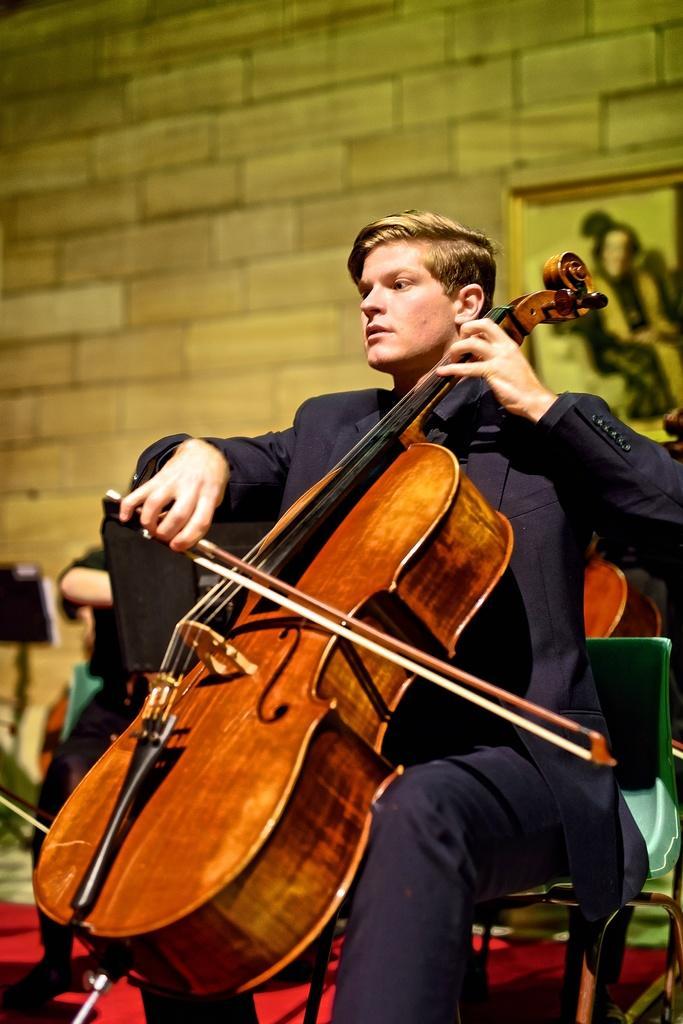In one or two sentences, can you explain what this image depicts? In this image, we can see a person sitting on a chair and playing a musical instrument. 